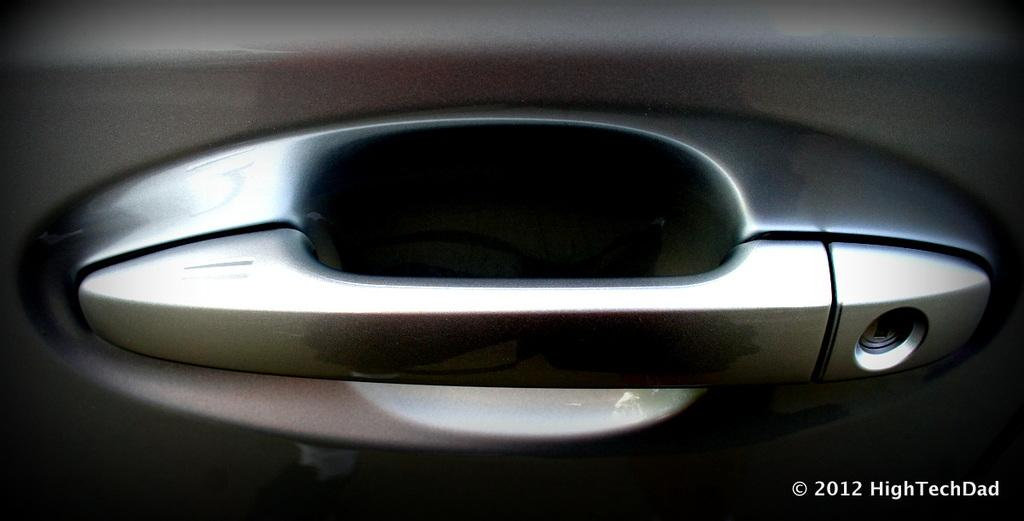What is the main subject of the image? The main subject of the image is a car door part. What feature does the car door part have? The car door part has a handle. Is there any text present in the image? Yes, there is text visible at the bottom of the image. How does the salt contribute to the humor in the image? There is no salt present in the image, and therefore it cannot contribute to any humor. 